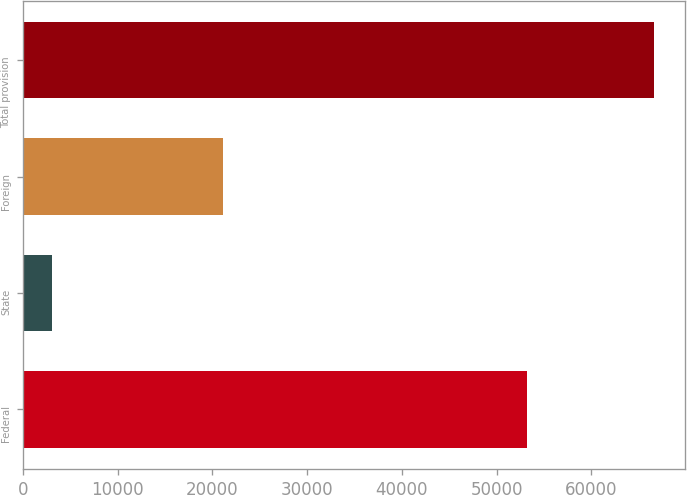Convert chart. <chart><loc_0><loc_0><loc_500><loc_500><bar_chart><fcel>Federal<fcel>State<fcel>Foreign<fcel>Total provision<nl><fcel>53187<fcel>3075<fcel>21138<fcel>66556<nl></chart> 